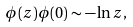<formula> <loc_0><loc_0><loc_500><loc_500>\phi ( z ) \phi ( 0 ) \sim - \ln z ,</formula> 